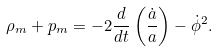Convert formula to latex. <formula><loc_0><loc_0><loc_500><loc_500>\rho _ { m } + p _ { m } = - 2 \frac { d } { d t } \left ( \frac { \dot { a } } { a } \right ) - \dot { \phi } ^ { 2 } .</formula> 